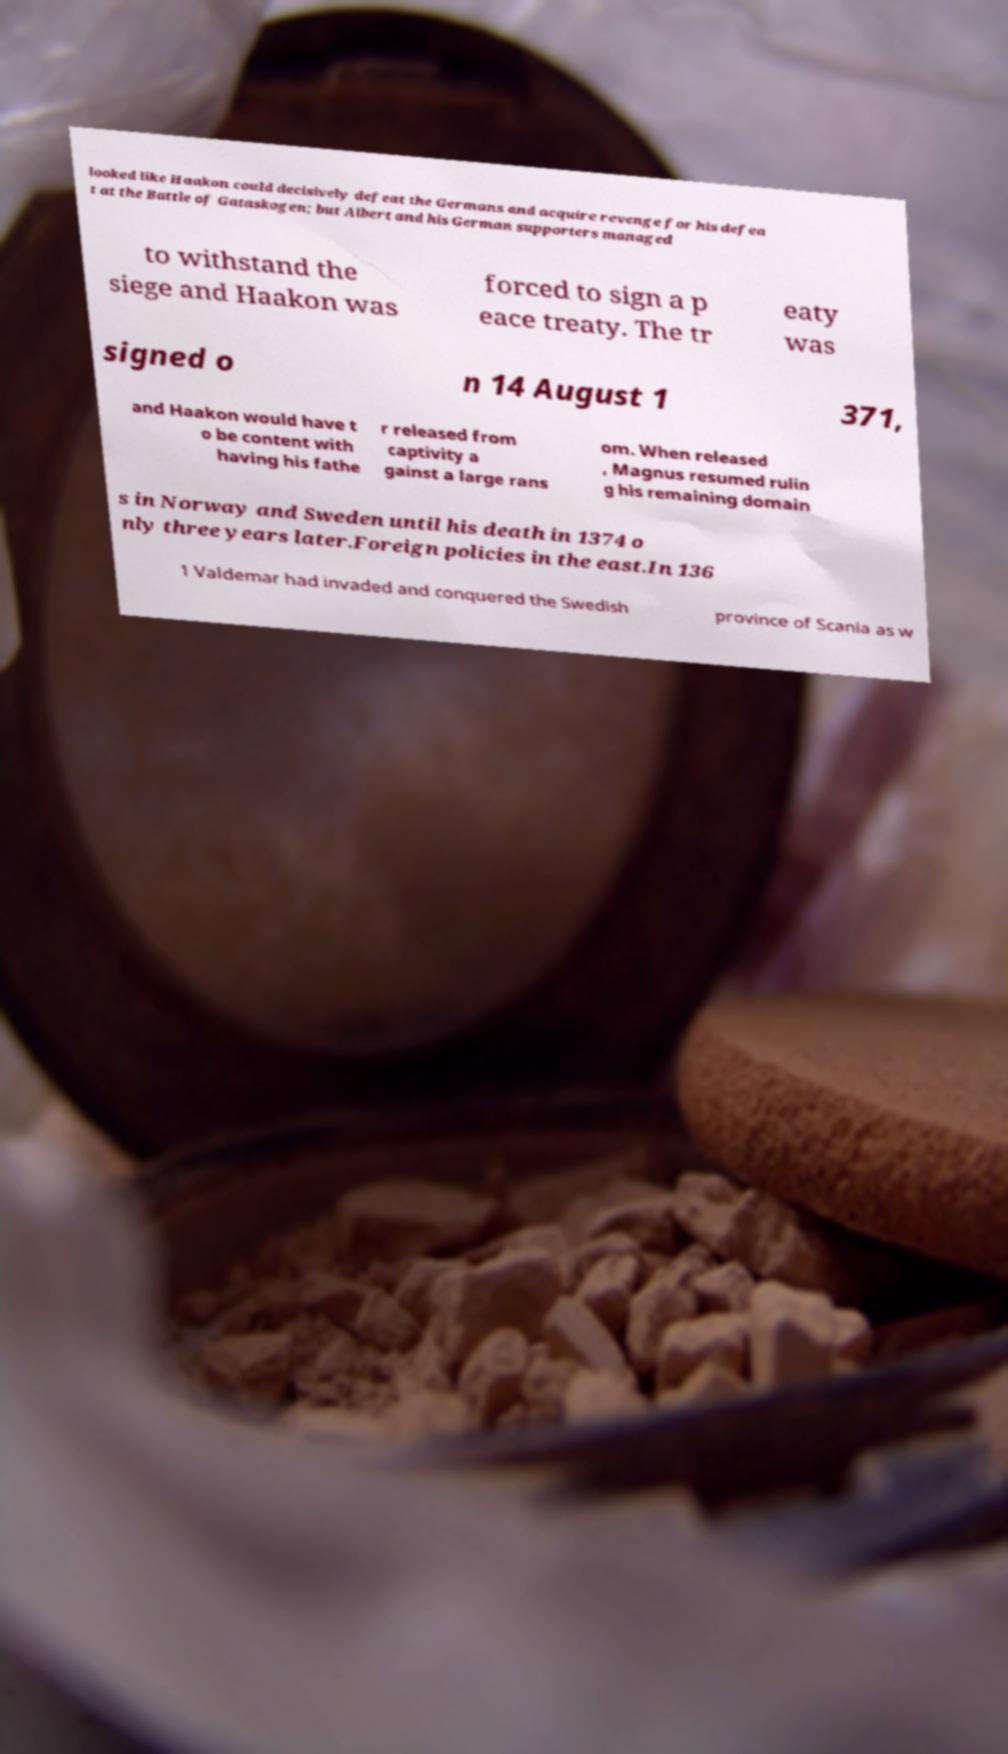Could you extract and type out the text from this image? looked like Haakon could decisively defeat the Germans and acquire revenge for his defea t at the Battle of Gataskogen; but Albert and his German supporters managed to withstand the siege and Haakon was forced to sign a p eace treaty. The tr eaty was signed o n 14 August 1 371, and Haakon would have t o be content with having his fathe r released from captivity a gainst a large rans om. When released , Magnus resumed rulin g his remaining domain s in Norway and Sweden until his death in 1374 o nly three years later.Foreign policies in the east.In 136 1 Valdemar had invaded and conquered the Swedish province of Scania as w 